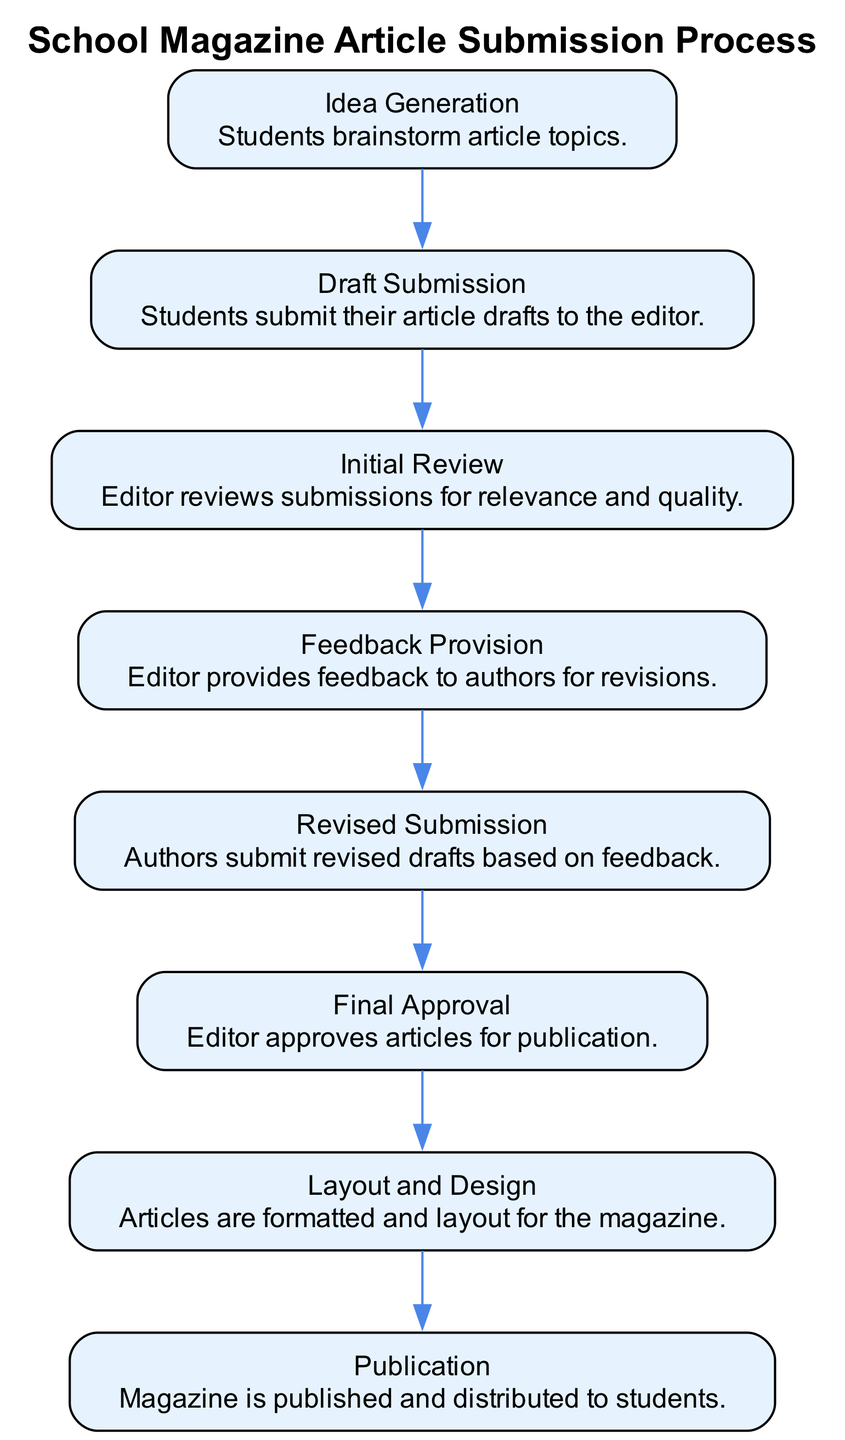What is the first step in the process? The first step is "Idea Generation," where students brainstorm article topics.
Answer: Idea Generation How many steps are involved in the process? Counting each step from the diagram, there are eight steps in total, starting from "Idea Generation" and ending with "Publication."
Answer: Eight What does the editor provide after the "Initial Review"? After the "Initial Review," the editor provides "Feedback Provision" for improvements to the articles.
Answer: Feedback Provision Which step occurs directly before "Final Approval"? The step directly before "Final Approval" is "Revised Submission," where authors submit improved drafts based on the feedback they received.
Answer: Revised Submission What is the final output of the process? The final output is the "Publication" where the magazine is published and distributed.
Answer: Publication Which step discusses formatting and design? The step that discusses formatting and design is "Layout and Design," where articles are prepared for publication.
Answer: Layout and Design How is the feedback delivered to authors in the process? Feedback is delivered to authors in the "Feedback Provision" step, where the editor gives comments and suggestions for revisions.
Answer: Feedback Provision What is the relationship between "Draft Submission" and "Initial Review"? The relationship is sequential; "Draft Submission" occurs first, followed by the "Initial Review" by the editor.
Answer: Sequential Which step occurs immediately after "Revised Submission"? "Final Approval" occurs immediately after "Revised Submission," indicating that the editor reviews the revised drafts before approving them.
Answer: Final Approval 